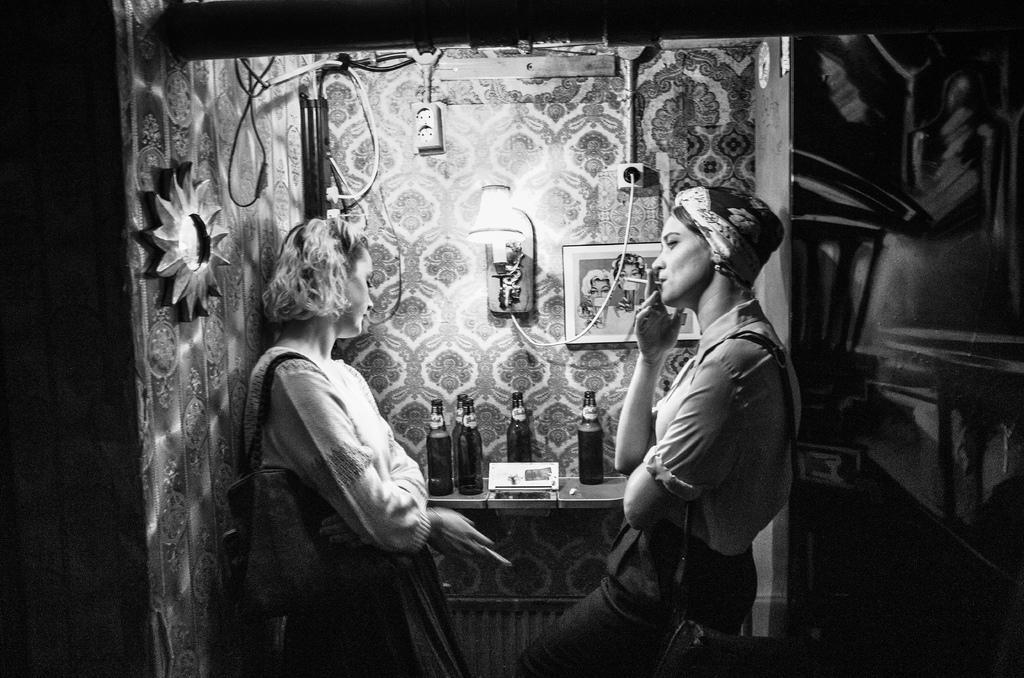In one or two sentences, can you explain what this image depicts? In this picture we can see two women, they are holding cigarettes, beside them we can see few bottles, light and a frame on the wall, it is a black and white photography. 